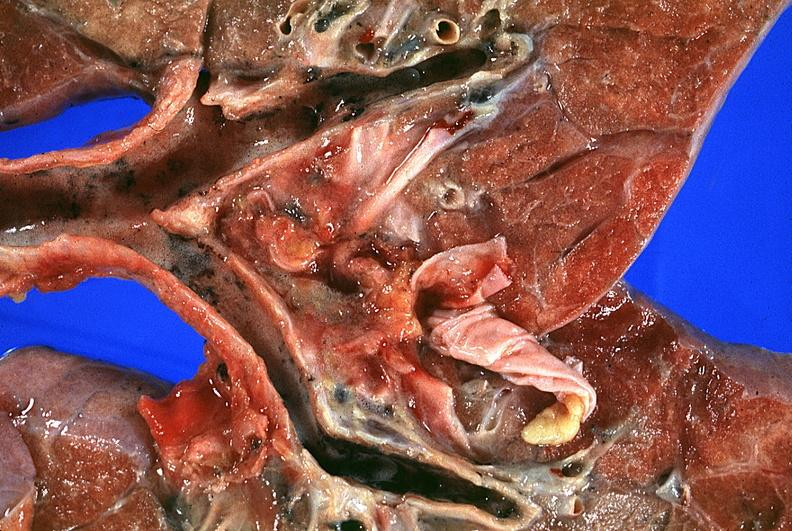what is present?
Answer the question using a single word or phrase. Respiratory 